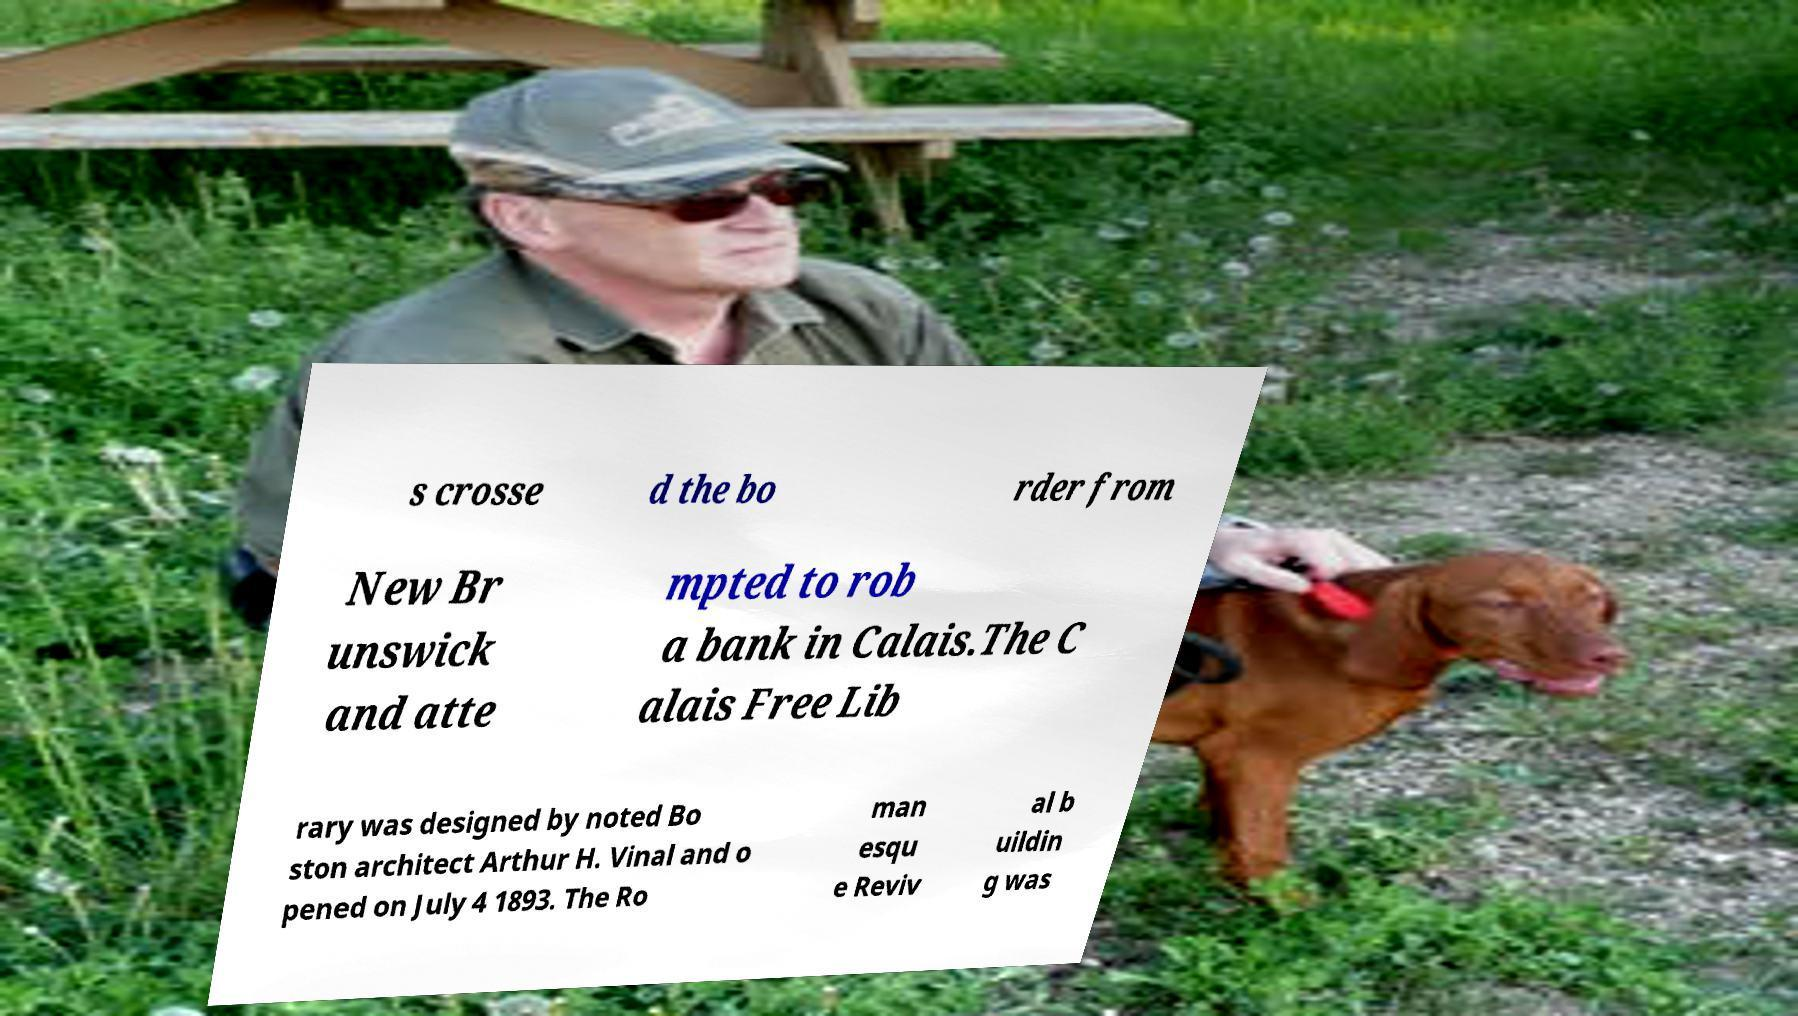Could you extract and type out the text from this image? s crosse d the bo rder from New Br unswick and atte mpted to rob a bank in Calais.The C alais Free Lib rary was designed by noted Bo ston architect Arthur H. Vinal and o pened on July 4 1893. The Ro man esqu e Reviv al b uildin g was 